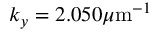<formula> <loc_0><loc_0><loc_500><loc_500>k _ { y } = 2 . 0 5 0 \mu m ^ { - 1 }</formula> 